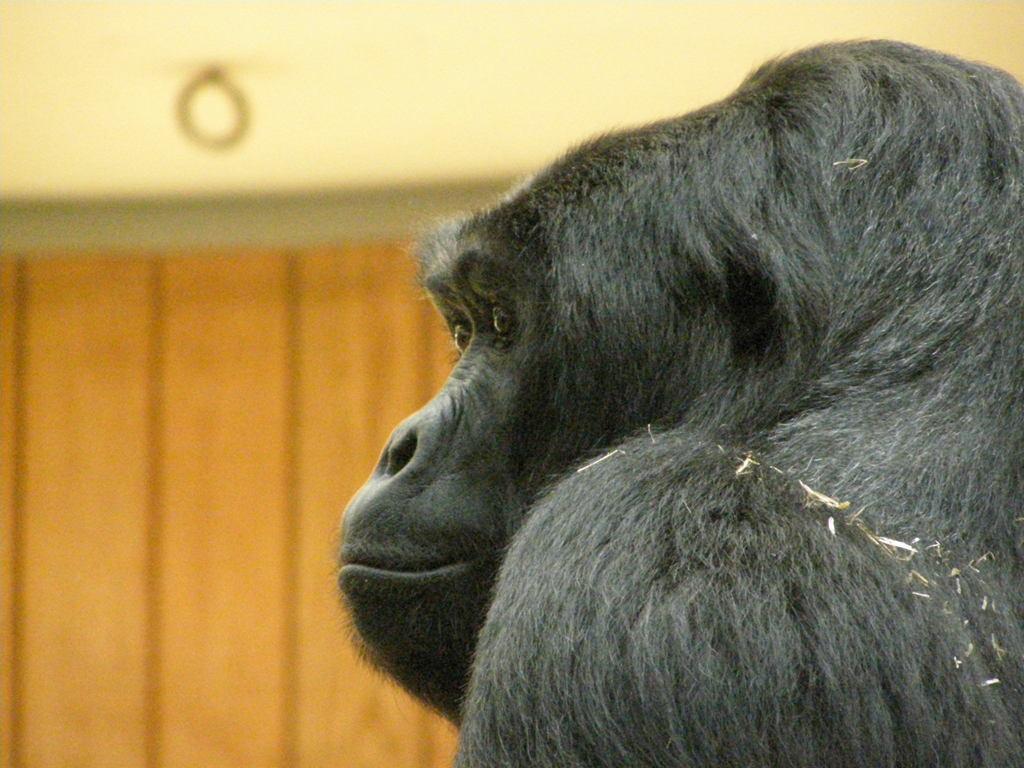Could you give a brief overview of what you see in this image? In the center of the image, there is a chimpanzee and in the background, there is a wall. 